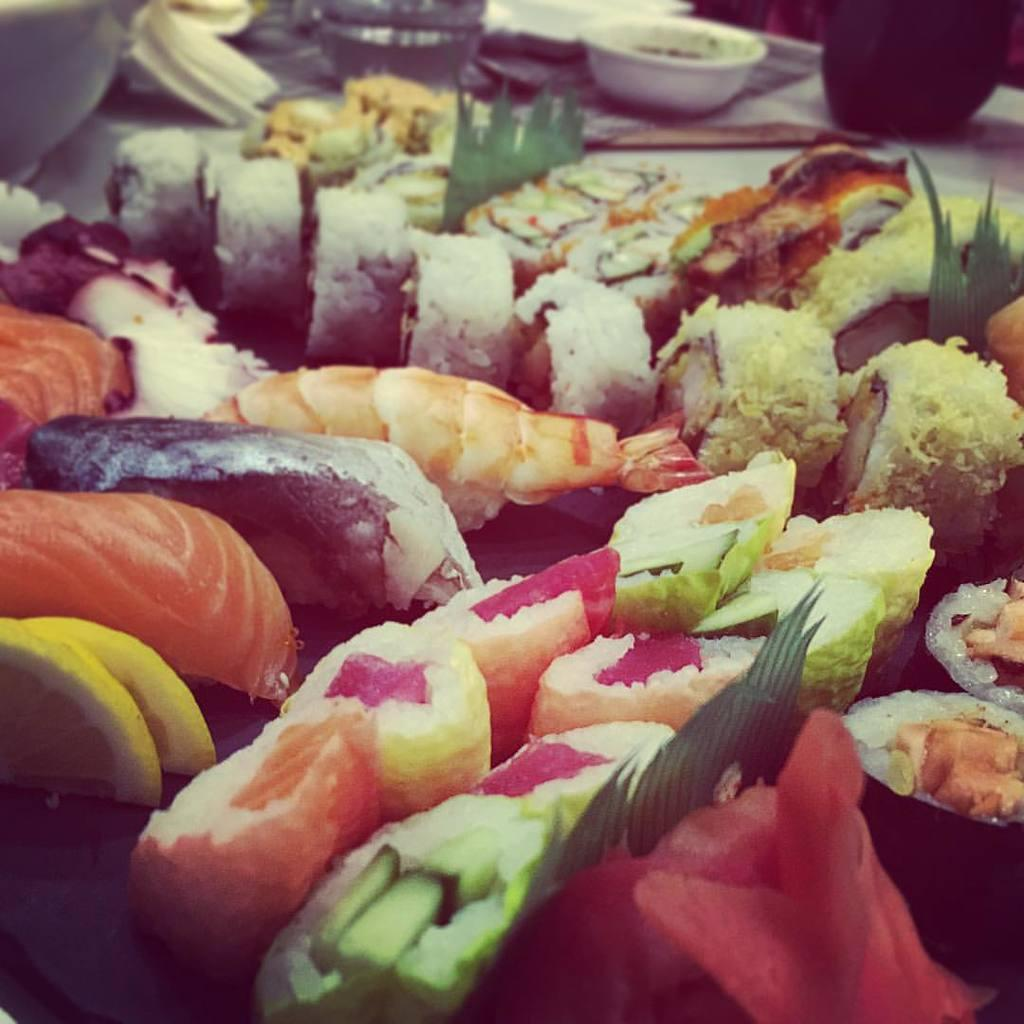What types of food items can be seen in the image? There are different varieties of food items in the image. Can you identify any specific food item among them? Yes, prawns are present among the food items. What is located in the background of the image? There is a bowl in the background of the image, along with other unspecified items. What book is being read by the prawn in the image? There is no book or prawn reading a book present in the image. 